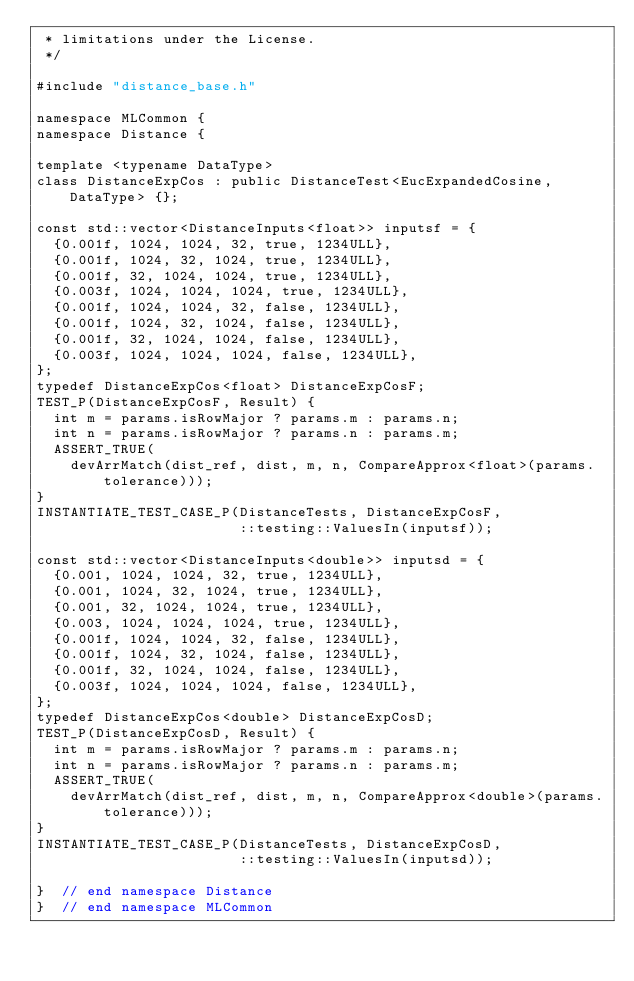<code> <loc_0><loc_0><loc_500><loc_500><_Cuda_> * limitations under the License.
 */

#include "distance_base.h"

namespace MLCommon {
namespace Distance {

template <typename DataType>
class DistanceExpCos : public DistanceTest<EucExpandedCosine, DataType> {};

const std::vector<DistanceInputs<float>> inputsf = {
  {0.001f, 1024, 1024, 32, true, 1234ULL},
  {0.001f, 1024, 32, 1024, true, 1234ULL},
  {0.001f, 32, 1024, 1024, true, 1234ULL},
  {0.003f, 1024, 1024, 1024, true, 1234ULL},
  {0.001f, 1024, 1024, 32, false, 1234ULL},
  {0.001f, 1024, 32, 1024, false, 1234ULL},
  {0.001f, 32, 1024, 1024, false, 1234ULL},
  {0.003f, 1024, 1024, 1024, false, 1234ULL},
};
typedef DistanceExpCos<float> DistanceExpCosF;
TEST_P(DistanceExpCosF, Result) {
  int m = params.isRowMajor ? params.m : params.n;
  int n = params.isRowMajor ? params.n : params.m;
  ASSERT_TRUE(
    devArrMatch(dist_ref, dist, m, n, CompareApprox<float>(params.tolerance)));
}
INSTANTIATE_TEST_CASE_P(DistanceTests, DistanceExpCosF,
                        ::testing::ValuesIn(inputsf));

const std::vector<DistanceInputs<double>> inputsd = {
  {0.001, 1024, 1024, 32, true, 1234ULL},
  {0.001, 1024, 32, 1024, true, 1234ULL},
  {0.001, 32, 1024, 1024, true, 1234ULL},
  {0.003, 1024, 1024, 1024, true, 1234ULL},
  {0.001f, 1024, 1024, 32, false, 1234ULL},
  {0.001f, 1024, 32, 1024, false, 1234ULL},
  {0.001f, 32, 1024, 1024, false, 1234ULL},
  {0.003f, 1024, 1024, 1024, false, 1234ULL},
};
typedef DistanceExpCos<double> DistanceExpCosD;
TEST_P(DistanceExpCosD, Result) {
  int m = params.isRowMajor ? params.m : params.n;
  int n = params.isRowMajor ? params.n : params.m;
  ASSERT_TRUE(
    devArrMatch(dist_ref, dist, m, n, CompareApprox<double>(params.tolerance)));
}
INSTANTIATE_TEST_CASE_P(DistanceTests, DistanceExpCosD,
                        ::testing::ValuesIn(inputsd));

}  // end namespace Distance
}  // end namespace MLCommon
</code> 